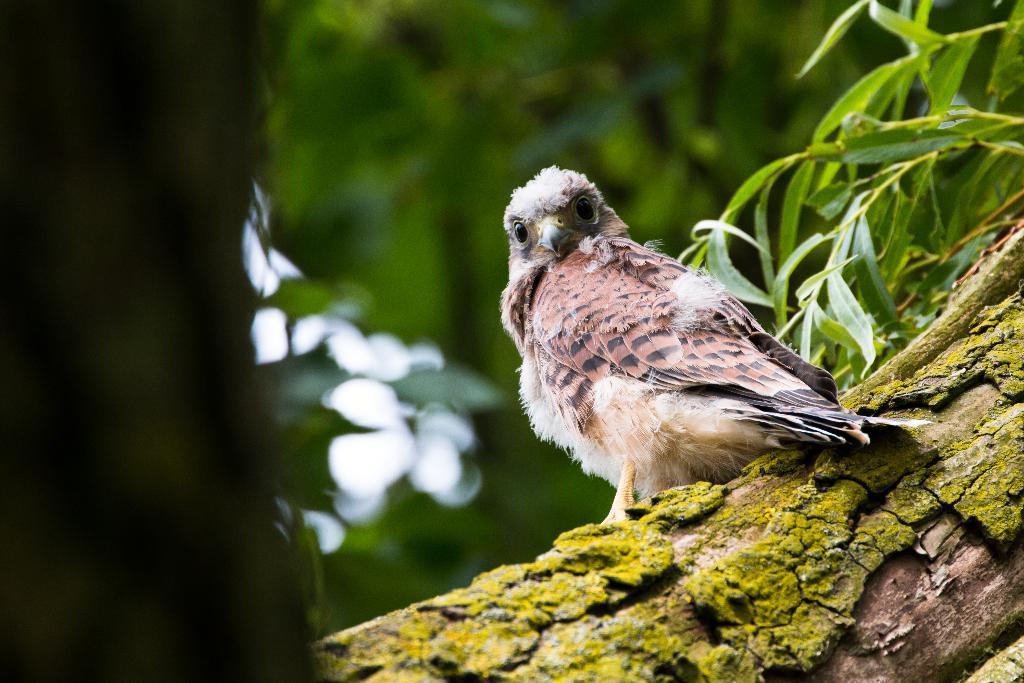How would you summarize this image in a sentence or two? In this image there is a tree trunk towards the bottom of the image, there is a bird, there is a plant, there is an object towards the left of the image, the background of the image is blurred. 